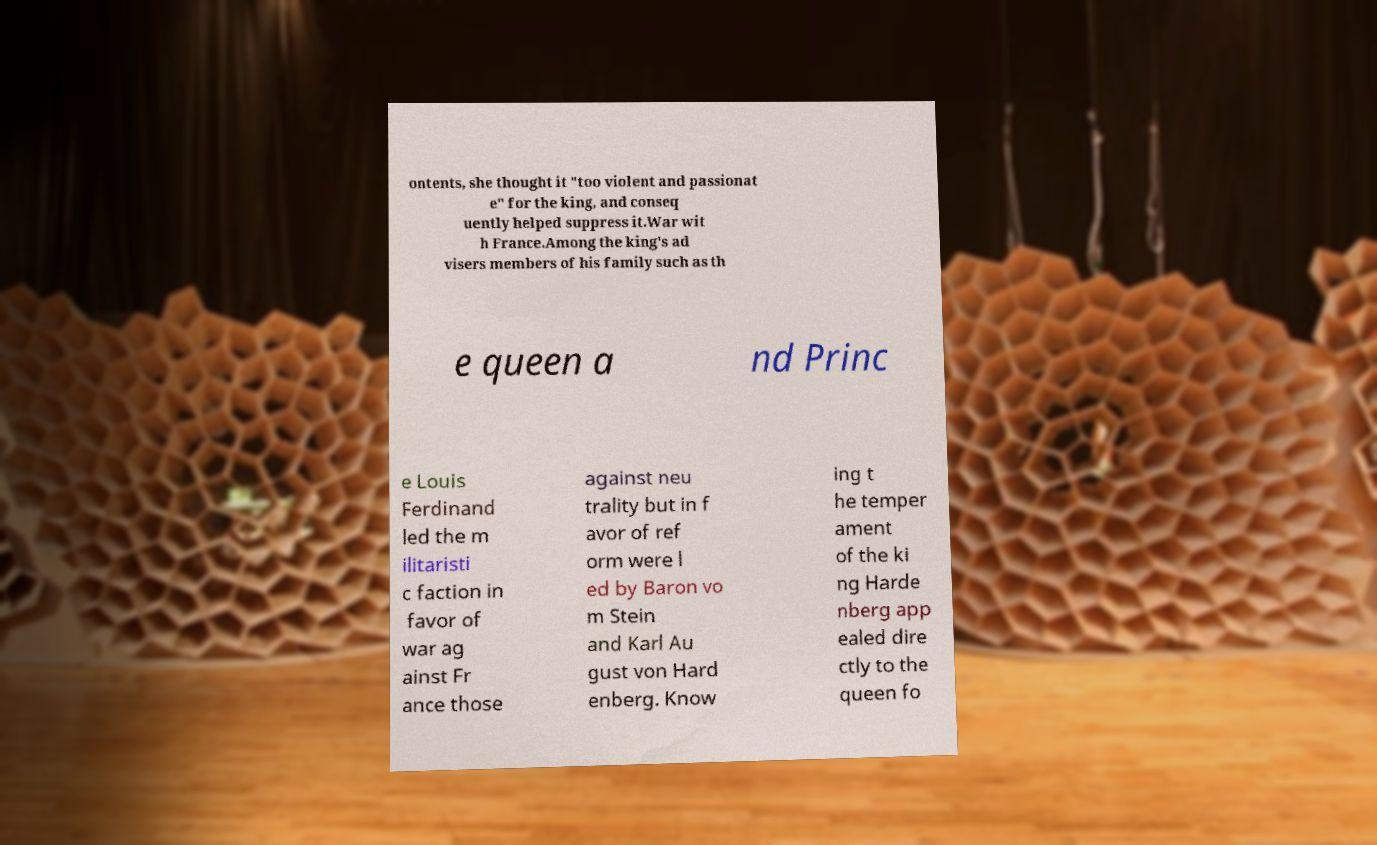There's text embedded in this image that I need extracted. Can you transcribe it verbatim? ontents, she thought it "too violent and passionat e" for the king, and conseq uently helped suppress it.War wit h France.Among the king's ad visers members of his family such as th e queen a nd Princ e Louis Ferdinand led the m ilitaristi c faction in favor of war ag ainst Fr ance those against neu trality but in f avor of ref orm were l ed by Baron vo m Stein and Karl Au gust von Hard enberg. Know ing t he temper ament of the ki ng Harde nberg app ealed dire ctly to the queen fo 